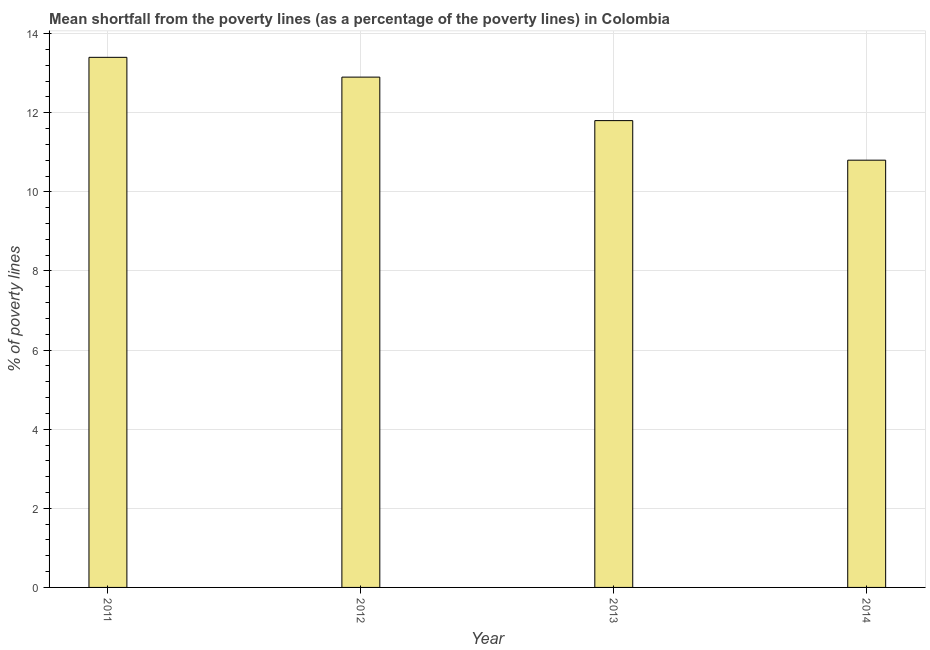Does the graph contain any zero values?
Your answer should be very brief. No. What is the title of the graph?
Give a very brief answer. Mean shortfall from the poverty lines (as a percentage of the poverty lines) in Colombia. What is the label or title of the Y-axis?
Offer a terse response. % of poverty lines. What is the poverty gap at national poverty lines in 2011?
Your response must be concise. 13.4. In which year was the poverty gap at national poverty lines maximum?
Your answer should be very brief. 2011. What is the sum of the poverty gap at national poverty lines?
Your answer should be compact. 48.9. What is the average poverty gap at national poverty lines per year?
Give a very brief answer. 12.22. What is the median poverty gap at national poverty lines?
Offer a terse response. 12.35. In how many years, is the poverty gap at national poverty lines greater than 10.8 %?
Provide a short and direct response. 3. What is the ratio of the poverty gap at national poverty lines in 2012 to that in 2013?
Provide a succinct answer. 1.09. Is the difference between the poverty gap at national poverty lines in 2012 and 2013 greater than the difference between any two years?
Your answer should be very brief. No. What is the difference between the highest and the second highest poverty gap at national poverty lines?
Your answer should be very brief. 0.5. Is the sum of the poverty gap at national poverty lines in 2011 and 2012 greater than the maximum poverty gap at national poverty lines across all years?
Offer a very short reply. Yes. How many bars are there?
Give a very brief answer. 4. Are all the bars in the graph horizontal?
Give a very brief answer. No. What is the % of poverty lines of 2011?
Offer a very short reply. 13.4. What is the % of poverty lines of 2012?
Offer a very short reply. 12.9. What is the % of poverty lines of 2013?
Provide a succinct answer. 11.8. What is the % of poverty lines in 2014?
Keep it short and to the point. 10.8. What is the difference between the % of poverty lines in 2012 and 2014?
Provide a short and direct response. 2.1. What is the difference between the % of poverty lines in 2013 and 2014?
Ensure brevity in your answer.  1. What is the ratio of the % of poverty lines in 2011 to that in 2012?
Provide a short and direct response. 1.04. What is the ratio of the % of poverty lines in 2011 to that in 2013?
Provide a short and direct response. 1.14. What is the ratio of the % of poverty lines in 2011 to that in 2014?
Offer a very short reply. 1.24. What is the ratio of the % of poverty lines in 2012 to that in 2013?
Offer a very short reply. 1.09. What is the ratio of the % of poverty lines in 2012 to that in 2014?
Your answer should be compact. 1.19. What is the ratio of the % of poverty lines in 2013 to that in 2014?
Offer a terse response. 1.09. 